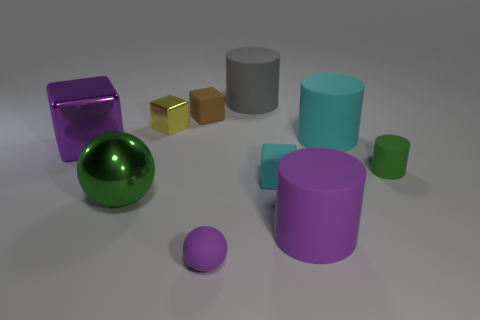Is there any other thing that is the same material as the purple cylinder? Yes, the small sphere appears to be made from the same glossy material as the purple cylinder, reflecting light in a similar manner. 